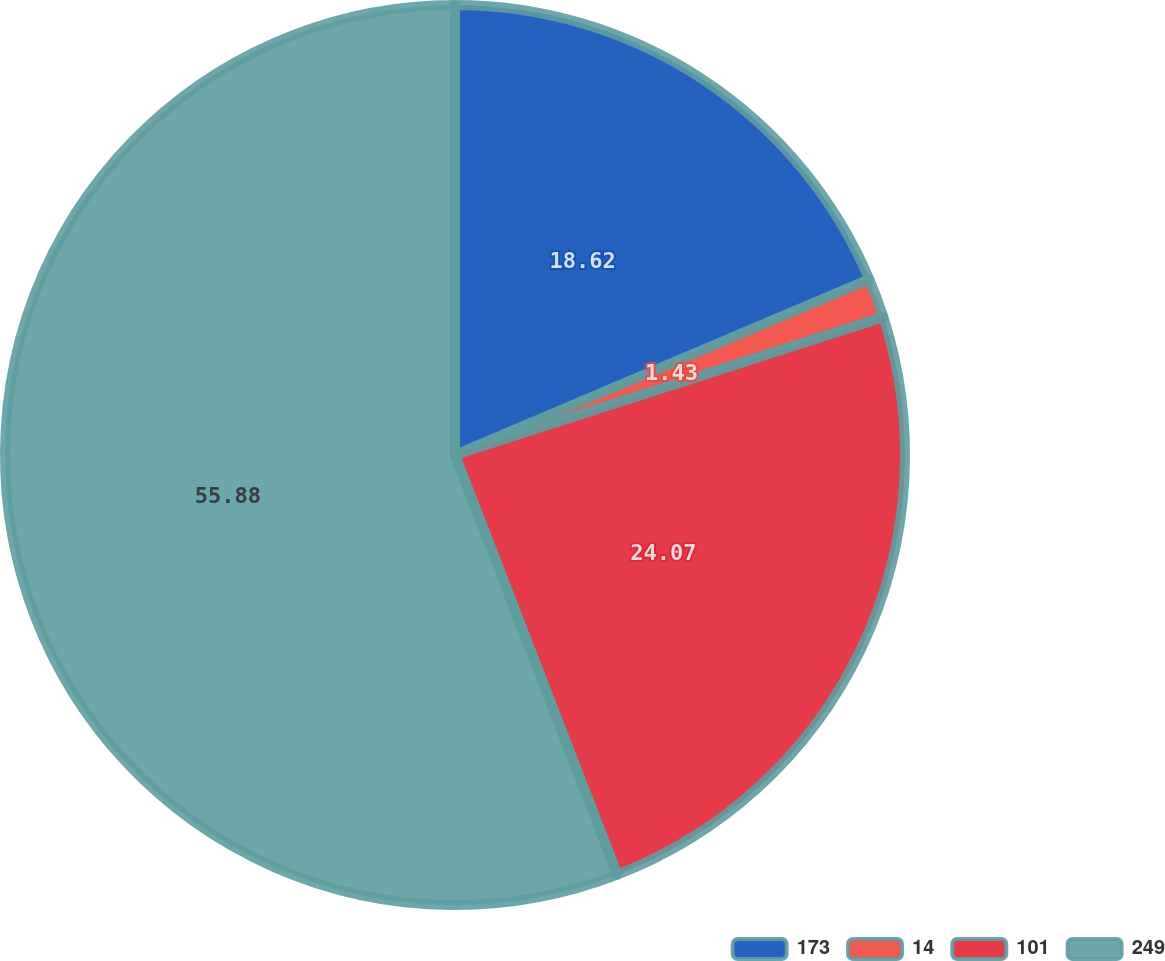Convert chart to OTSL. <chart><loc_0><loc_0><loc_500><loc_500><pie_chart><fcel>173<fcel>14<fcel>101<fcel>249<nl><fcel>18.62%<fcel>1.43%<fcel>24.07%<fcel>55.87%<nl></chart> 